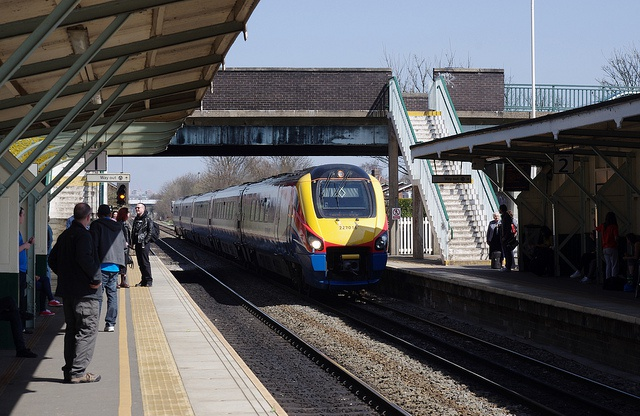Describe the objects in this image and their specific colors. I can see train in gray, black, darkgray, and navy tones, people in gray and black tones, people in gray, black, and darkgray tones, people in gray, black, and navy tones, and people in gray, black, and darkgray tones in this image. 